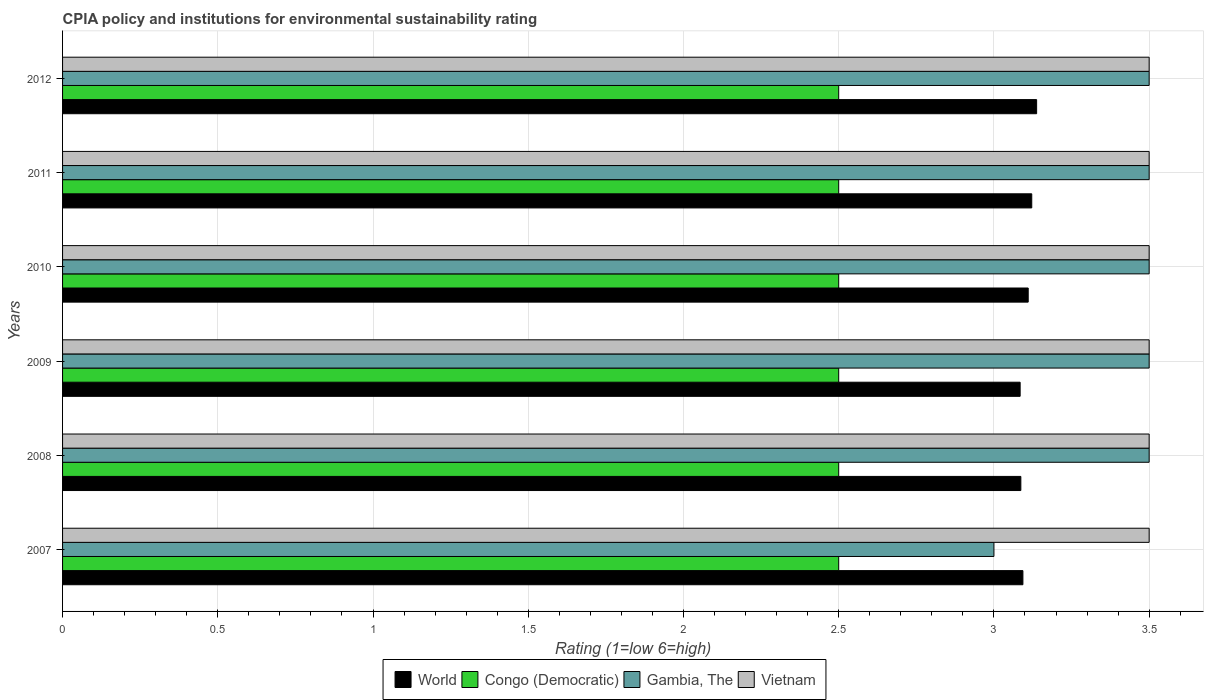How many groups of bars are there?
Keep it short and to the point. 6. In how many cases, is the number of bars for a given year not equal to the number of legend labels?
Give a very brief answer. 0. What is the CPIA rating in Vietnam in 2012?
Offer a very short reply. 3.5. Across all years, what is the maximum CPIA rating in Congo (Democratic)?
Your answer should be compact. 2.5. What is the total CPIA rating in Congo (Democratic) in the graph?
Offer a very short reply. 15. What is the difference between the CPIA rating in World in 2010 and that in 2012?
Keep it short and to the point. -0.03. In the year 2009, what is the difference between the CPIA rating in World and CPIA rating in Gambia, The?
Make the answer very short. -0.42. In how many years, is the CPIA rating in Vietnam greater than 1.3 ?
Offer a terse response. 6. What is the ratio of the CPIA rating in Congo (Democratic) in 2007 to that in 2011?
Ensure brevity in your answer.  1. Is the CPIA rating in Congo (Democratic) in 2009 less than that in 2010?
Ensure brevity in your answer.  No. What is the difference between the highest and the lowest CPIA rating in Vietnam?
Provide a short and direct response. 0. What does the 3rd bar from the top in 2010 represents?
Your response must be concise. Congo (Democratic). What does the 1st bar from the bottom in 2007 represents?
Offer a very short reply. World. Is it the case that in every year, the sum of the CPIA rating in Vietnam and CPIA rating in World is greater than the CPIA rating in Gambia, The?
Your answer should be very brief. Yes. Does the graph contain any zero values?
Make the answer very short. No. How many legend labels are there?
Give a very brief answer. 4. How are the legend labels stacked?
Your answer should be compact. Horizontal. What is the title of the graph?
Keep it short and to the point. CPIA policy and institutions for environmental sustainability rating. What is the label or title of the X-axis?
Ensure brevity in your answer.  Rating (1=low 6=high). What is the Rating (1=low 6=high) in World in 2007?
Provide a short and direct response. 3.09. What is the Rating (1=low 6=high) of Congo (Democratic) in 2007?
Your response must be concise. 2.5. What is the Rating (1=low 6=high) of World in 2008?
Provide a short and direct response. 3.09. What is the Rating (1=low 6=high) in Congo (Democratic) in 2008?
Your answer should be compact. 2.5. What is the Rating (1=low 6=high) of Gambia, The in 2008?
Give a very brief answer. 3.5. What is the Rating (1=low 6=high) in Vietnam in 2008?
Ensure brevity in your answer.  3.5. What is the Rating (1=low 6=high) in World in 2009?
Give a very brief answer. 3.08. What is the Rating (1=low 6=high) in Congo (Democratic) in 2009?
Make the answer very short. 2.5. What is the Rating (1=low 6=high) in World in 2010?
Keep it short and to the point. 3.11. What is the Rating (1=low 6=high) of Congo (Democratic) in 2010?
Keep it short and to the point. 2.5. What is the Rating (1=low 6=high) in Vietnam in 2010?
Make the answer very short. 3.5. What is the Rating (1=low 6=high) in World in 2011?
Give a very brief answer. 3.12. What is the Rating (1=low 6=high) in Congo (Democratic) in 2011?
Give a very brief answer. 2.5. What is the Rating (1=low 6=high) of World in 2012?
Your answer should be compact. 3.14. Across all years, what is the maximum Rating (1=low 6=high) in World?
Offer a very short reply. 3.14. Across all years, what is the maximum Rating (1=low 6=high) in Vietnam?
Make the answer very short. 3.5. Across all years, what is the minimum Rating (1=low 6=high) of World?
Provide a short and direct response. 3.08. Across all years, what is the minimum Rating (1=low 6=high) of Vietnam?
Your response must be concise. 3.5. What is the total Rating (1=low 6=high) of World in the graph?
Provide a succinct answer. 18.63. What is the total Rating (1=low 6=high) in Congo (Democratic) in the graph?
Provide a succinct answer. 15. What is the total Rating (1=low 6=high) in Vietnam in the graph?
Ensure brevity in your answer.  21. What is the difference between the Rating (1=low 6=high) in World in 2007 and that in 2008?
Provide a succinct answer. 0.01. What is the difference between the Rating (1=low 6=high) in Gambia, The in 2007 and that in 2008?
Make the answer very short. -0.5. What is the difference between the Rating (1=low 6=high) in Vietnam in 2007 and that in 2008?
Keep it short and to the point. 0. What is the difference between the Rating (1=low 6=high) in World in 2007 and that in 2009?
Provide a succinct answer. 0.01. What is the difference between the Rating (1=low 6=high) in Gambia, The in 2007 and that in 2009?
Provide a succinct answer. -0.5. What is the difference between the Rating (1=low 6=high) of World in 2007 and that in 2010?
Your answer should be very brief. -0.02. What is the difference between the Rating (1=low 6=high) of Congo (Democratic) in 2007 and that in 2010?
Your answer should be compact. 0. What is the difference between the Rating (1=low 6=high) of Vietnam in 2007 and that in 2010?
Give a very brief answer. 0. What is the difference between the Rating (1=low 6=high) of World in 2007 and that in 2011?
Your answer should be very brief. -0.03. What is the difference between the Rating (1=low 6=high) of Gambia, The in 2007 and that in 2011?
Your answer should be very brief. -0.5. What is the difference between the Rating (1=low 6=high) of Vietnam in 2007 and that in 2011?
Provide a short and direct response. 0. What is the difference between the Rating (1=low 6=high) in World in 2007 and that in 2012?
Make the answer very short. -0.04. What is the difference between the Rating (1=low 6=high) in Gambia, The in 2007 and that in 2012?
Your answer should be very brief. -0.5. What is the difference between the Rating (1=low 6=high) in World in 2008 and that in 2009?
Your answer should be very brief. 0. What is the difference between the Rating (1=low 6=high) in Gambia, The in 2008 and that in 2009?
Your answer should be compact. 0. What is the difference between the Rating (1=low 6=high) in World in 2008 and that in 2010?
Give a very brief answer. -0.02. What is the difference between the Rating (1=low 6=high) in Gambia, The in 2008 and that in 2010?
Ensure brevity in your answer.  0. What is the difference between the Rating (1=low 6=high) in Vietnam in 2008 and that in 2010?
Your response must be concise. 0. What is the difference between the Rating (1=low 6=high) in World in 2008 and that in 2011?
Give a very brief answer. -0.04. What is the difference between the Rating (1=low 6=high) of Congo (Democratic) in 2008 and that in 2011?
Keep it short and to the point. 0. What is the difference between the Rating (1=low 6=high) of Vietnam in 2008 and that in 2011?
Provide a succinct answer. 0. What is the difference between the Rating (1=low 6=high) of World in 2008 and that in 2012?
Your answer should be compact. -0.05. What is the difference between the Rating (1=low 6=high) of Gambia, The in 2008 and that in 2012?
Give a very brief answer. 0. What is the difference between the Rating (1=low 6=high) of World in 2009 and that in 2010?
Provide a succinct answer. -0.03. What is the difference between the Rating (1=low 6=high) of Vietnam in 2009 and that in 2010?
Give a very brief answer. 0. What is the difference between the Rating (1=low 6=high) in World in 2009 and that in 2011?
Your response must be concise. -0.04. What is the difference between the Rating (1=low 6=high) of Vietnam in 2009 and that in 2011?
Offer a very short reply. 0. What is the difference between the Rating (1=low 6=high) of World in 2009 and that in 2012?
Ensure brevity in your answer.  -0.05. What is the difference between the Rating (1=low 6=high) of World in 2010 and that in 2011?
Your response must be concise. -0.01. What is the difference between the Rating (1=low 6=high) of Congo (Democratic) in 2010 and that in 2011?
Your response must be concise. 0. What is the difference between the Rating (1=low 6=high) of World in 2010 and that in 2012?
Offer a terse response. -0.03. What is the difference between the Rating (1=low 6=high) of Gambia, The in 2010 and that in 2012?
Provide a short and direct response. 0. What is the difference between the Rating (1=low 6=high) in World in 2011 and that in 2012?
Your response must be concise. -0.02. What is the difference between the Rating (1=low 6=high) of Vietnam in 2011 and that in 2012?
Keep it short and to the point. 0. What is the difference between the Rating (1=low 6=high) in World in 2007 and the Rating (1=low 6=high) in Congo (Democratic) in 2008?
Your answer should be compact. 0.59. What is the difference between the Rating (1=low 6=high) of World in 2007 and the Rating (1=low 6=high) of Gambia, The in 2008?
Provide a succinct answer. -0.41. What is the difference between the Rating (1=low 6=high) in World in 2007 and the Rating (1=low 6=high) in Vietnam in 2008?
Make the answer very short. -0.41. What is the difference between the Rating (1=low 6=high) in Gambia, The in 2007 and the Rating (1=low 6=high) in Vietnam in 2008?
Make the answer very short. -0.5. What is the difference between the Rating (1=low 6=high) in World in 2007 and the Rating (1=low 6=high) in Congo (Democratic) in 2009?
Make the answer very short. 0.59. What is the difference between the Rating (1=low 6=high) of World in 2007 and the Rating (1=low 6=high) of Gambia, The in 2009?
Offer a very short reply. -0.41. What is the difference between the Rating (1=low 6=high) in World in 2007 and the Rating (1=low 6=high) in Vietnam in 2009?
Your response must be concise. -0.41. What is the difference between the Rating (1=low 6=high) in Congo (Democratic) in 2007 and the Rating (1=low 6=high) in Gambia, The in 2009?
Offer a terse response. -1. What is the difference between the Rating (1=low 6=high) of World in 2007 and the Rating (1=low 6=high) of Congo (Democratic) in 2010?
Your answer should be very brief. 0.59. What is the difference between the Rating (1=low 6=high) of World in 2007 and the Rating (1=low 6=high) of Gambia, The in 2010?
Offer a very short reply. -0.41. What is the difference between the Rating (1=low 6=high) of World in 2007 and the Rating (1=low 6=high) of Vietnam in 2010?
Offer a terse response. -0.41. What is the difference between the Rating (1=low 6=high) in Congo (Democratic) in 2007 and the Rating (1=low 6=high) in Vietnam in 2010?
Keep it short and to the point. -1. What is the difference between the Rating (1=low 6=high) of World in 2007 and the Rating (1=low 6=high) of Congo (Democratic) in 2011?
Your answer should be compact. 0.59. What is the difference between the Rating (1=low 6=high) of World in 2007 and the Rating (1=low 6=high) of Gambia, The in 2011?
Your response must be concise. -0.41. What is the difference between the Rating (1=low 6=high) of World in 2007 and the Rating (1=low 6=high) of Vietnam in 2011?
Your answer should be very brief. -0.41. What is the difference between the Rating (1=low 6=high) of Congo (Democratic) in 2007 and the Rating (1=low 6=high) of Gambia, The in 2011?
Make the answer very short. -1. What is the difference between the Rating (1=low 6=high) in World in 2007 and the Rating (1=low 6=high) in Congo (Democratic) in 2012?
Provide a succinct answer. 0.59. What is the difference between the Rating (1=low 6=high) in World in 2007 and the Rating (1=low 6=high) in Gambia, The in 2012?
Offer a very short reply. -0.41. What is the difference between the Rating (1=low 6=high) of World in 2007 and the Rating (1=low 6=high) of Vietnam in 2012?
Make the answer very short. -0.41. What is the difference between the Rating (1=low 6=high) of Congo (Democratic) in 2007 and the Rating (1=low 6=high) of Gambia, The in 2012?
Make the answer very short. -1. What is the difference between the Rating (1=low 6=high) of Congo (Democratic) in 2007 and the Rating (1=low 6=high) of Vietnam in 2012?
Keep it short and to the point. -1. What is the difference between the Rating (1=low 6=high) of World in 2008 and the Rating (1=low 6=high) of Congo (Democratic) in 2009?
Offer a very short reply. 0.59. What is the difference between the Rating (1=low 6=high) of World in 2008 and the Rating (1=low 6=high) of Gambia, The in 2009?
Your response must be concise. -0.41. What is the difference between the Rating (1=low 6=high) in World in 2008 and the Rating (1=low 6=high) in Vietnam in 2009?
Offer a terse response. -0.41. What is the difference between the Rating (1=low 6=high) in Congo (Democratic) in 2008 and the Rating (1=low 6=high) in Gambia, The in 2009?
Provide a short and direct response. -1. What is the difference between the Rating (1=low 6=high) of Congo (Democratic) in 2008 and the Rating (1=low 6=high) of Vietnam in 2009?
Ensure brevity in your answer.  -1. What is the difference between the Rating (1=low 6=high) of World in 2008 and the Rating (1=low 6=high) of Congo (Democratic) in 2010?
Offer a terse response. 0.59. What is the difference between the Rating (1=low 6=high) of World in 2008 and the Rating (1=low 6=high) of Gambia, The in 2010?
Provide a succinct answer. -0.41. What is the difference between the Rating (1=low 6=high) in World in 2008 and the Rating (1=low 6=high) in Vietnam in 2010?
Provide a succinct answer. -0.41. What is the difference between the Rating (1=low 6=high) in Congo (Democratic) in 2008 and the Rating (1=low 6=high) in Gambia, The in 2010?
Give a very brief answer. -1. What is the difference between the Rating (1=low 6=high) in Gambia, The in 2008 and the Rating (1=low 6=high) in Vietnam in 2010?
Your answer should be compact. 0. What is the difference between the Rating (1=low 6=high) in World in 2008 and the Rating (1=low 6=high) in Congo (Democratic) in 2011?
Offer a very short reply. 0.59. What is the difference between the Rating (1=low 6=high) in World in 2008 and the Rating (1=low 6=high) in Gambia, The in 2011?
Offer a terse response. -0.41. What is the difference between the Rating (1=low 6=high) of World in 2008 and the Rating (1=low 6=high) of Vietnam in 2011?
Offer a terse response. -0.41. What is the difference between the Rating (1=low 6=high) in Gambia, The in 2008 and the Rating (1=low 6=high) in Vietnam in 2011?
Your answer should be very brief. 0. What is the difference between the Rating (1=low 6=high) in World in 2008 and the Rating (1=low 6=high) in Congo (Democratic) in 2012?
Provide a succinct answer. 0.59. What is the difference between the Rating (1=low 6=high) of World in 2008 and the Rating (1=low 6=high) of Gambia, The in 2012?
Provide a short and direct response. -0.41. What is the difference between the Rating (1=low 6=high) in World in 2008 and the Rating (1=low 6=high) in Vietnam in 2012?
Keep it short and to the point. -0.41. What is the difference between the Rating (1=low 6=high) of Congo (Democratic) in 2008 and the Rating (1=low 6=high) of Gambia, The in 2012?
Give a very brief answer. -1. What is the difference between the Rating (1=low 6=high) of Congo (Democratic) in 2008 and the Rating (1=low 6=high) of Vietnam in 2012?
Ensure brevity in your answer.  -1. What is the difference between the Rating (1=low 6=high) in World in 2009 and the Rating (1=low 6=high) in Congo (Democratic) in 2010?
Ensure brevity in your answer.  0.58. What is the difference between the Rating (1=low 6=high) of World in 2009 and the Rating (1=low 6=high) of Gambia, The in 2010?
Offer a terse response. -0.42. What is the difference between the Rating (1=low 6=high) of World in 2009 and the Rating (1=low 6=high) of Vietnam in 2010?
Provide a succinct answer. -0.42. What is the difference between the Rating (1=low 6=high) in Congo (Democratic) in 2009 and the Rating (1=low 6=high) in Gambia, The in 2010?
Make the answer very short. -1. What is the difference between the Rating (1=low 6=high) of Congo (Democratic) in 2009 and the Rating (1=low 6=high) of Vietnam in 2010?
Ensure brevity in your answer.  -1. What is the difference between the Rating (1=low 6=high) in Gambia, The in 2009 and the Rating (1=low 6=high) in Vietnam in 2010?
Your answer should be very brief. 0. What is the difference between the Rating (1=low 6=high) in World in 2009 and the Rating (1=low 6=high) in Congo (Democratic) in 2011?
Provide a short and direct response. 0.58. What is the difference between the Rating (1=low 6=high) in World in 2009 and the Rating (1=low 6=high) in Gambia, The in 2011?
Provide a succinct answer. -0.42. What is the difference between the Rating (1=low 6=high) of World in 2009 and the Rating (1=low 6=high) of Vietnam in 2011?
Give a very brief answer. -0.42. What is the difference between the Rating (1=low 6=high) of Congo (Democratic) in 2009 and the Rating (1=low 6=high) of Gambia, The in 2011?
Give a very brief answer. -1. What is the difference between the Rating (1=low 6=high) in Congo (Democratic) in 2009 and the Rating (1=low 6=high) in Vietnam in 2011?
Your answer should be very brief. -1. What is the difference between the Rating (1=low 6=high) of Gambia, The in 2009 and the Rating (1=low 6=high) of Vietnam in 2011?
Your answer should be compact. 0. What is the difference between the Rating (1=low 6=high) of World in 2009 and the Rating (1=low 6=high) of Congo (Democratic) in 2012?
Your response must be concise. 0.58. What is the difference between the Rating (1=low 6=high) of World in 2009 and the Rating (1=low 6=high) of Gambia, The in 2012?
Provide a short and direct response. -0.42. What is the difference between the Rating (1=low 6=high) in World in 2009 and the Rating (1=low 6=high) in Vietnam in 2012?
Give a very brief answer. -0.42. What is the difference between the Rating (1=low 6=high) of Congo (Democratic) in 2009 and the Rating (1=low 6=high) of Vietnam in 2012?
Ensure brevity in your answer.  -1. What is the difference between the Rating (1=low 6=high) in World in 2010 and the Rating (1=low 6=high) in Congo (Democratic) in 2011?
Provide a succinct answer. 0.61. What is the difference between the Rating (1=low 6=high) of World in 2010 and the Rating (1=low 6=high) of Gambia, The in 2011?
Offer a very short reply. -0.39. What is the difference between the Rating (1=low 6=high) in World in 2010 and the Rating (1=low 6=high) in Vietnam in 2011?
Offer a terse response. -0.39. What is the difference between the Rating (1=low 6=high) in Congo (Democratic) in 2010 and the Rating (1=low 6=high) in Gambia, The in 2011?
Provide a succinct answer. -1. What is the difference between the Rating (1=low 6=high) of World in 2010 and the Rating (1=low 6=high) of Congo (Democratic) in 2012?
Your response must be concise. 0.61. What is the difference between the Rating (1=low 6=high) of World in 2010 and the Rating (1=low 6=high) of Gambia, The in 2012?
Keep it short and to the point. -0.39. What is the difference between the Rating (1=low 6=high) of World in 2010 and the Rating (1=low 6=high) of Vietnam in 2012?
Your answer should be compact. -0.39. What is the difference between the Rating (1=low 6=high) in Congo (Democratic) in 2010 and the Rating (1=low 6=high) in Gambia, The in 2012?
Your answer should be very brief. -1. What is the difference between the Rating (1=low 6=high) in Congo (Democratic) in 2010 and the Rating (1=low 6=high) in Vietnam in 2012?
Provide a short and direct response. -1. What is the difference between the Rating (1=low 6=high) of Gambia, The in 2010 and the Rating (1=low 6=high) of Vietnam in 2012?
Your answer should be compact. 0. What is the difference between the Rating (1=low 6=high) of World in 2011 and the Rating (1=low 6=high) of Congo (Democratic) in 2012?
Provide a succinct answer. 0.62. What is the difference between the Rating (1=low 6=high) of World in 2011 and the Rating (1=low 6=high) of Gambia, The in 2012?
Make the answer very short. -0.38. What is the difference between the Rating (1=low 6=high) of World in 2011 and the Rating (1=low 6=high) of Vietnam in 2012?
Give a very brief answer. -0.38. What is the difference between the Rating (1=low 6=high) in Congo (Democratic) in 2011 and the Rating (1=low 6=high) in Gambia, The in 2012?
Keep it short and to the point. -1. What is the average Rating (1=low 6=high) of World per year?
Provide a succinct answer. 3.11. What is the average Rating (1=low 6=high) in Gambia, The per year?
Ensure brevity in your answer.  3.42. What is the average Rating (1=low 6=high) of Vietnam per year?
Offer a terse response. 3.5. In the year 2007, what is the difference between the Rating (1=low 6=high) in World and Rating (1=low 6=high) in Congo (Democratic)?
Keep it short and to the point. 0.59. In the year 2007, what is the difference between the Rating (1=low 6=high) of World and Rating (1=low 6=high) of Gambia, The?
Offer a very short reply. 0.09. In the year 2007, what is the difference between the Rating (1=low 6=high) in World and Rating (1=low 6=high) in Vietnam?
Your answer should be very brief. -0.41. In the year 2007, what is the difference between the Rating (1=low 6=high) of Congo (Democratic) and Rating (1=low 6=high) of Vietnam?
Offer a very short reply. -1. In the year 2008, what is the difference between the Rating (1=low 6=high) of World and Rating (1=low 6=high) of Congo (Democratic)?
Your response must be concise. 0.59. In the year 2008, what is the difference between the Rating (1=low 6=high) of World and Rating (1=low 6=high) of Gambia, The?
Your answer should be very brief. -0.41. In the year 2008, what is the difference between the Rating (1=low 6=high) of World and Rating (1=low 6=high) of Vietnam?
Your answer should be very brief. -0.41. In the year 2008, what is the difference between the Rating (1=low 6=high) in Congo (Democratic) and Rating (1=low 6=high) in Gambia, The?
Offer a very short reply. -1. In the year 2009, what is the difference between the Rating (1=low 6=high) of World and Rating (1=low 6=high) of Congo (Democratic)?
Ensure brevity in your answer.  0.58. In the year 2009, what is the difference between the Rating (1=low 6=high) in World and Rating (1=low 6=high) in Gambia, The?
Keep it short and to the point. -0.42. In the year 2009, what is the difference between the Rating (1=low 6=high) in World and Rating (1=low 6=high) in Vietnam?
Provide a short and direct response. -0.42. In the year 2009, what is the difference between the Rating (1=low 6=high) of Gambia, The and Rating (1=low 6=high) of Vietnam?
Your answer should be compact. 0. In the year 2010, what is the difference between the Rating (1=low 6=high) in World and Rating (1=low 6=high) in Congo (Democratic)?
Offer a very short reply. 0.61. In the year 2010, what is the difference between the Rating (1=low 6=high) of World and Rating (1=low 6=high) of Gambia, The?
Your response must be concise. -0.39. In the year 2010, what is the difference between the Rating (1=low 6=high) of World and Rating (1=low 6=high) of Vietnam?
Your response must be concise. -0.39. In the year 2010, what is the difference between the Rating (1=low 6=high) of Congo (Democratic) and Rating (1=low 6=high) of Vietnam?
Your answer should be very brief. -1. In the year 2010, what is the difference between the Rating (1=low 6=high) in Gambia, The and Rating (1=low 6=high) in Vietnam?
Your response must be concise. 0. In the year 2011, what is the difference between the Rating (1=low 6=high) in World and Rating (1=low 6=high) in Congo (Democratic)?
Provide a succinct answer. 0.62. In the year 2011, what is the difference between the Rating (1=low 6=high) in World and Rating (1=low 6=high) in Gambia, The?
Ensure brevity in your answer.  -0.38. In the year 2011, what is the difference between the Rating (1=low 6=high) of World and Rating (1=low 6=high) of Vietnam?
Make the answer very short. -0.38. In the year 2012, what is the difference between the Rating (1=low 6=high) of World and Rating (1=low 6=high) of Congo (Democratic)?
Provide a succinct answer. 0.64. In the year 2012, what is the difference between the Rating (1=low 6=high) in World and Rating (1=low 6=high) in Gambia, The?
Provide a short and direct response. -0.36. In the year 2012, what is the difference between the Rating (1=low 6=high) in World and Rating (1=low 6=high) in Vietnam?
Your answer should be compact. -0.36. In the year 2012, what is the difference between the Rating (1=low 6=high) in Congo (Democratic) and Rating (1=low 6=high) in Gambia, The?
Offer a terse response. -1. In the year 2012, what is the difference between the Rating (1=low 6=high) in Gambia, The and Rating (1=low 6=high) in Vietnam?
Ensure brevity in your answer.  0. What is the ratio of the Rating (1=low 6=high) in World in 2007 to that in 2008?
Provide a succinct answer. 1. What is the ratio of the Rating (1=low 6=high) in Vietnam in 2007 to that in 2008?
Ensure brevity in your answer.  1. What is the ratio of the Rating (1=low 6=high) in Gambia, The in 2007 to that in 2009?
Offer a terse response. 0.86. What is the ratio of the Rating (1=low 6=high) in Vietnam in 2007 to that in 2009?
Ensure brevity in your answer.  1. What is the ratio of the Rating (1=low 6=high) of World in 2007 to that in 2010?
Offer a terse response. 0.99. What is the ratio of the Rating (1=low 6=high) of Gambia, The in 2007 to that in 2010?
Give a very brief answer. 0.86. What is the ratio of the Rating (1=low 6=high) of Vietnam in 2007 to that in 2010?
Keep it short and to the point. 1. What is the ratio of the Rating (1=low 6=high) in World in 2007 to that in 2011?
Make the answer very short. 0.99. What is the ratio of the Rating (1=low 6=high) in Congo (Democratic) in 2007 to that in 2011?
Offer a terse response. 1. What is the ratio of the Rating (1=low 6=high) in World in 2007 to that in 2012?
Keep it short and to the point. 0.99. What is the ratio of the Rating (1=low 6=high) of Gambia, The in 2007 to that in 2012?
Make the answer very short. 0.86. What is the ratio of the Rating (1=low 6=high) in World in 2008 to that in 2009?
Ensure brevity in your answer.  1. What is the ratio of the Rating (1=low 6=high) in World in 2008 to that in 2010?
Provide a short and direct response. 0.99. What is the ratio of the Rating (1=low 6=high) in World in 2008 to that in 2011?
Offer a terse response. 0.99. What is the ratio of the Rating (1=low 6=high) in Gambia, The in 2008 to that in 2011?
Make the answer very short. 1. What is the ratio of the Rating (1=low 6=high) in World in 2008 to that in 2012?
Make the answer very short. 0.98. What is the ratio of the Rating (1=low 6=high) in Congo (Democratic) in 2009 to that in 2010?
Give a very brief answer. 1. What is the ratio of the Rating (1=low 6=high) in Vietnam in 2009 to that in 2011?
Make the answer very short. 1. What is the ratio of the Rating (1=low 6=high) of World in 2009 to that in 2012?
Your answer should be very brief. 0.98. What is the ratio of the Rating (1=low 6=high) in Congo (Democratic) in 2009 to that in 2012?
Offer a very short reply. 1. What is the ratio of the Rating (1=low 6=high) of Gambia, The in 2009 to that in 2012?
Offer a terse response. 1. What is the ratio of the Rating (1=low 6=high) in Gambia, The in 2010 to that in 2011?
Make the answer very short. 1. What is the ratio of the Rating (1=low 6=high) in Vietnam in 2010 to that in 2012?
Make the answer very short. 1. What is the ratio of the Rating (1=low 6=high) in World in 2011 to that in 2012?
Your answer should be compact. 0.99. What is the difference between the highest and the second highest Rating (1=low 6=high) in World?
Provide a succinct answer. 0.02. What is the difference between the highest and the second highest Rating (1=low 6=high) of Vietnam?
Provide a succinct answer. 0. What is the difference between the highest and the lowest Rating (1=low 6=high) of World?
Give a very brief answer. 0.05. What is the difference between the highest and the lowest Rating (1=low 6=high) of Gambia, The?
Your answer should be very brief. 0.5. What is the difference between the highest and the lowest Rating (1=low 6=high) of Vietnam?
Ensure brevity in your answer.  0. 